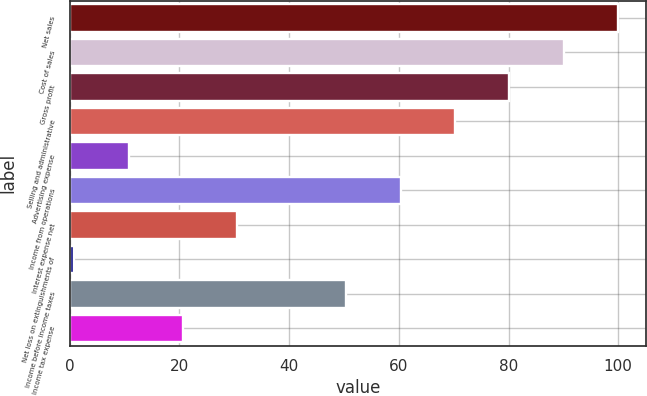Convert chart to OTSL. <chart><loc_0><loc_0><loc_500><loc_500><bar_chart><fcel>Net sales<fcel>Cost of sales<fcel>Gross profit<fcel>Selling and administrative<fcel>Advertising expense<fcel>Income from operations<fcel>Interest expense net<fcel>Net loss on extinguishments of<fcel>Income before income taxes<fcel>Income tax expense<nl><fcel>100<fcel>90.08<fcel>80.16<fcel>70.24<fcel>10.72<fcel>60.32<fcel>30.56<fcel>0.8<fcel>50.4<fcel>20.64<nl></chart> 